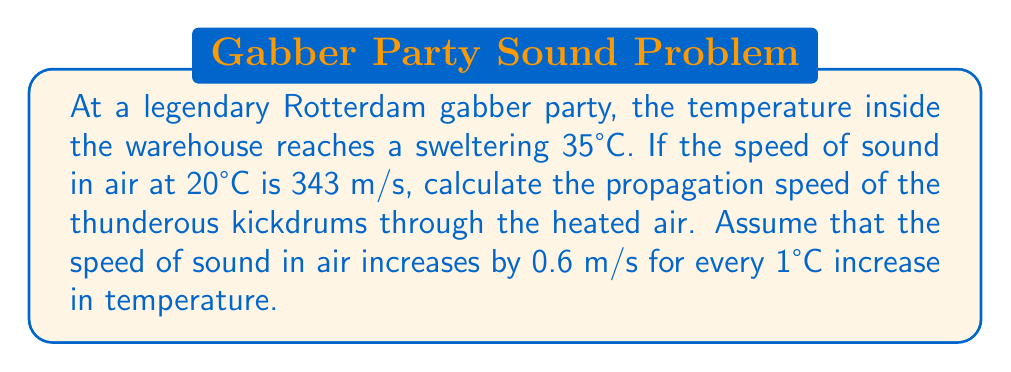Can you solve this math problem? Let's approach this step-by-step:

1) First, we need to determine the temperature difference:
   $\Delta T = 35°C - 20°C = 15°C$

2) We're given that the speed of sound increases by 0.6 m/s for every 1°C increase. So for a 15°C increase, the change in speed will be:
   $\Delta v = 15 \times 0.6 = 9$ m/s

3) Now, we can calculate the new speed of sound by adding this change to the original speed:
   $$v_{new} = v_{original} + \Delta v$$
   $$v_{new} = 343 + 9 = 352$$ m/s

4) Therefore, the propagation speed of sound waves (kickdrums) in the heated warehouse air is 352 m/s.

This increased speed means that the intense beats of the gabber music will reach the ravers slightly faster than they would at room temperature, enhancing the immersive experience of the hardcore party.
Answer: 352 m/s 